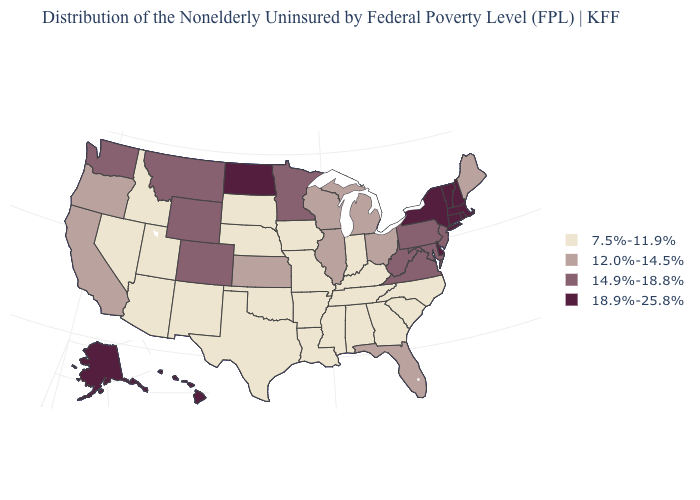What is the highest value in the MidWest ?
Write a very short answer. 18.9%-25.8%. Is the legend a continuous bar?
Short answer required. No. Which states have the lowest value in the South?
Concise answer only. Alabama, Arkansas, Georgia, Kentucky, Louisiana, Mississippi, North Carolina, Oklahoma, South Carolina, Tennessee, Texas. What is the highest value in the West ?
Quick response, please. 18.9%-25.8%. What is the lowest value in the USA?
Concise answer only. 7.5%-11.9%. Name the states that have a value in the range 18.9%-25.8%?
Be succinct. Alaska, Connecticut, Delaware, Hawaii, Massachusetts, New Hampshire, New York, North Dakota, Rhode Island, Vermont. What is the highest value in the USA?
Write a very short answer. 18.9%-25.8%. What is the lowest value in the USA?
Quick response, please. 7.5%-11.9%. Among the states that border Michigan , does Wisconsin have the lowest value?
Give a very brief answer. No. Does the first symbol in the legend represent the smallest category?
Answer briefly. Yes. Name the states that have a value in the range 14.9%-18.8%?
Answer briefly. Colorado, Maryland, Minnesota, Montana, New Jersey, Pennsylvania, Virginia, Washington, West Virginia, Wyoming. Name the states that have a value in the range 12.0%-14.5%?
Quick response, please. California, Florida, Illinois, Kansas, Maine, Michigan, Ohio, Oregon, Wisconsin. Does the map have missing data?
Write a very short answer. No. What is the highest value in the South ?
Concise answer only. 18.9%-25.8%. 